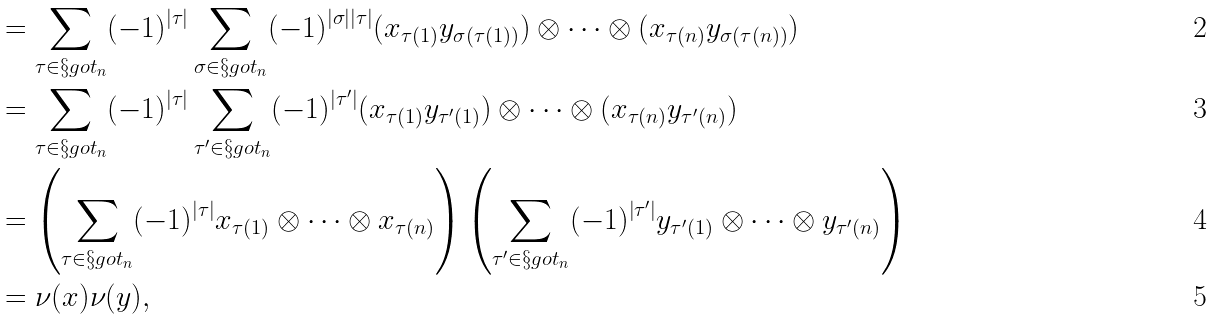<formula> <loc_0><loc_0><loc_500><loc_500>& = \sum _ { \tau \in \S g o t _ { n } } ( - 1 ) ^ { | \tau | } \sum _ { \sigma \in \S g o t _ { n } } ( - 1 ) ^ { | \sigma | | \tau | } ( x _ { \tau ( 1 ) } y _ { \sigma ( \tau ( 1 ) ) } ) \otimes \dots \otimes ( x _ { \tau ( n ) } y _ { \sigma ( \tau ( n ) ) } ) \\ & = \sum _ { \tau \in \S g o t _ { n } } ( - 1 ) ^ { | \tau | } \sum _ { \tau ^ { \prime } \in \S g o t _ { n } } ( - 1 ) ^ { | \tau ^ { \prime } | } ( x _ { \tau ( 1 ) } y _ { \tau ^ { \prime } ( 1 ) } ) \otimes \dots \otimes ( x _ { \tau ( n ) } y _ { \tau ^ { \prime } ( n ) } ) \\ & = \left ( \sum _ { \tau \in \S g o t _ { n } } ( - 1 ) ^ { | \tau | } x _ { \tau ( 1 ) } \otimes \dots \otimes x _ { \tau ( n ) } \right ) \left ( \sum _ { \tau ^ { \prime } \in \S g o t _ { n } } ( - 1 ) ^ { | \tau ^ { \prime } | } y _ { \tau ^ { \prime } ( 1 ) } \otimes \dots \otimes y _ { \tau ^ { \prime } ( n ) } \right ) \\ & = \nu ( x ) \nu ( y ) ,</formula> 